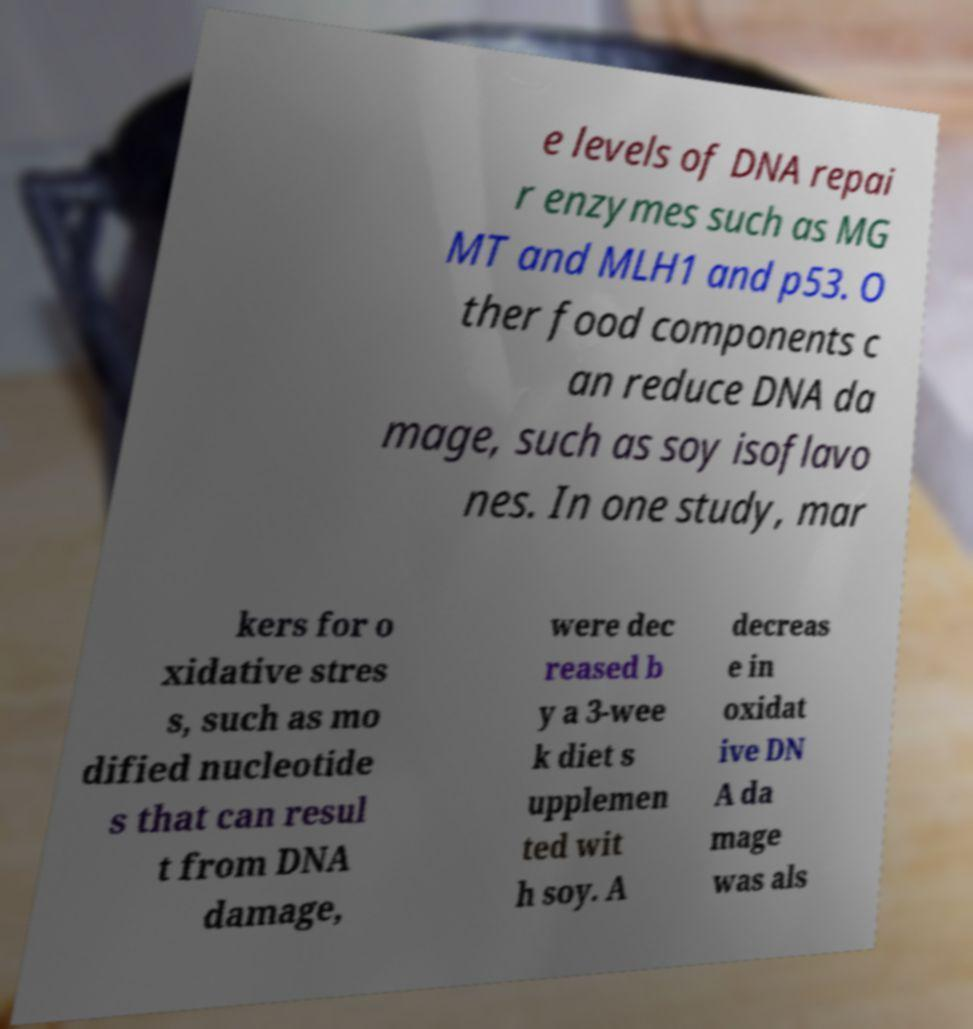Could you extract and type out the text from this image? e levels of DNA repai r enzymes such as MG MT and MLH1 and p53. O ther food components c an reduce DNA da mage, such as soy isoflavo nes. In one study, mar kers for o xidative stres s, such as mo dified nucleotide s that can resul t from DNA damage, were dec reased b y a 3-wee k diet s upplemen ted wit h soy. A decreas e in oxidat ive DN A da mage was als 